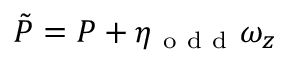Convert formula to latex. <formula><loc_0><loc_0><loc_500><loc_500>\tilde { P } = P + \eta _ { o d d } \omega _ { z }</formula> 